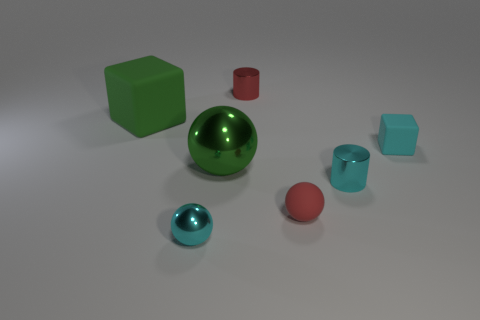Add 3 rubber spheres. How many objects exist? 10 Subtract all cylinders. How many objects are left? 5 Add 5 tiny cyan matte objects. How many tiny cyan matte objects are left? 6 Add 3 big green matte objects. How many big green matte objects exist? 4 Subtract 1 green spheres. How many objects are left? 6 Subtract all tiny cyan balls. Subtract all big green shiny spheres. How many objects are left? 5 